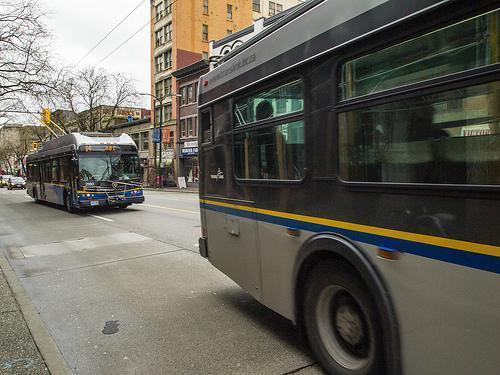How many buses are there?
Give a very brief answer. 2. 